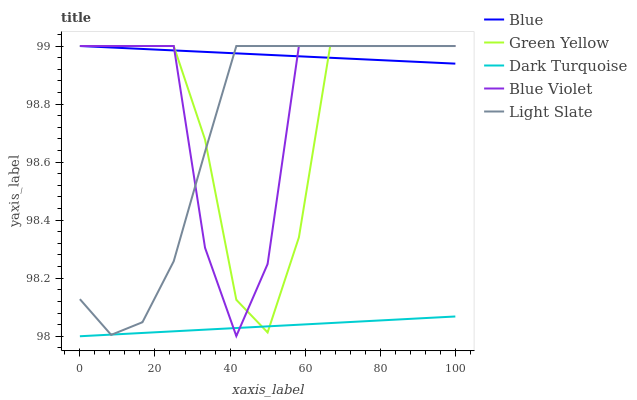Does Dark Turquoise have the minimum area under the curve?
Answer yes or no. Yes. Does Blue have the maximum area under the curve?
Answer yes or no. Yes. Does Light Slate have the minimum area under the curve?
Answer yes or no. No. Does Light Slate have the maximum area under the curve?
Answer yes or no. No. Is Dark Turquoise the smoothest?
Answer yes or no. Yes. Is Blue Violet the roughest?
Answer yes or no. Yes. Is Light Slate the smoothest?
Answer yes or no. No. Is Light Slate the roughest?
Answer yes or no. No. Does Dark Turquoise have the lowest value?
Answer yes or no. Yes. Does Light Slate have the lowest value?
Answer yes or no. No. Does Blue Violet have the highest value?
Answer yes or no. Yes. Does Dark Turquoise have the highest value?
Answer yes or no. No. Is Dark Turquoise less than Blue?
Answer yes or no. Yes. Is Blue greater than Dark Turquoise?
Answer yes or no. Yes. Does Dark Turquoise intersect Light Slate?
Answer yes or no. Yes. Is Dark Turquoise less than Light Slate?
Answer yes or no. No. Is Dark Turquoise greater than Light Slate?
Answer yes or no. No. Does Dark Turquoise intersect Blue?
Answer yes or no. No. 